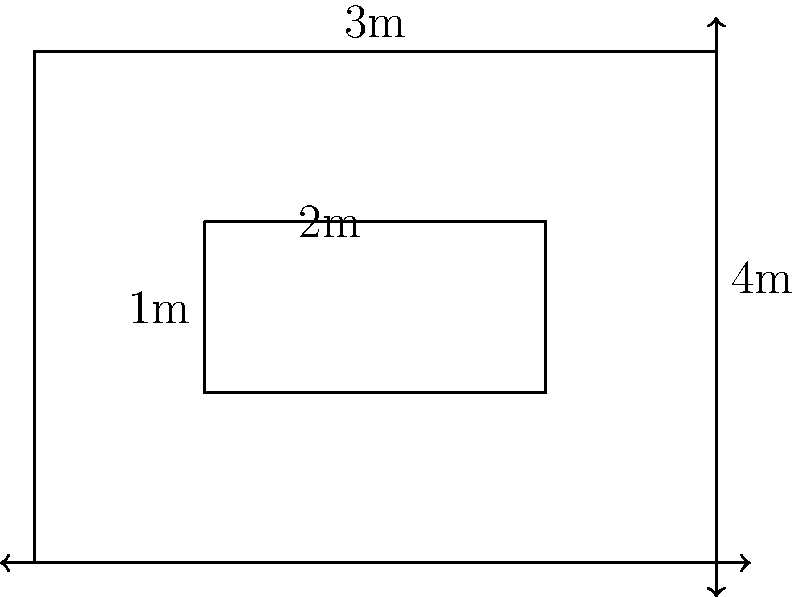As part of your lightweight aircraft design, you need to calculate the volume of a custom-shaped fuel tank. The tank is a rectangular prism with a smaller rectangular prism removed from its center, as shown in the diagram. The outer dimensions of the tank are 4m x 3m x 2m, while the inner removed section is 2m x 1m x 2m. What is the volume of the fuel tank in cubic meters? To calculate the volume of the custom-shaped fuel tank, we need to follow these steps:

1. Calculate the volume of the entire rectangular prism:
   $$V_{outer} = length \times width \times height$$
   $$V_{outer} = 4m \times 3m \times 2m = 24m^3$$

2. Calculate the volume of the removed inner section:
   $$V_{inner} = length \times width \times height$$
   $$V_{inner} = 2m \times 1m \times 2m = 4m^3$$

3. Subtract the volume of the inner section from the outer volume:
   $$V_{tank} = V_{outer} - V_{inner}$$
   $$V_{tank} = 24m^3 - 4m^3 = 20m^3$$

Therefore, the volume of the fuel tank is 20 cubic meters.
Answer: 20m³ 